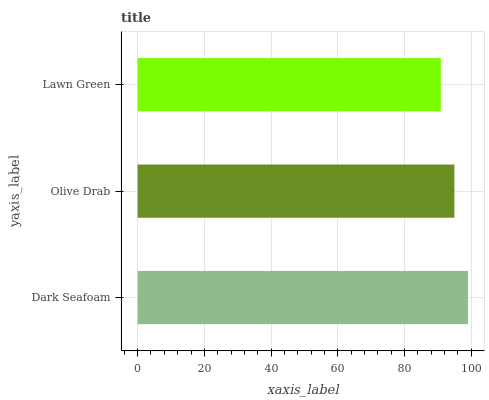Is Lawn Green the minimum?
Answer yes or no. Yes. Is Dark Seafoam the maximum?
Answer yes or no. Yes. Is Olive Drab the minimum?
Answer yes or no. No. Is Olive Drab the maximum?
Answer yes or no. No. Is Dark Seafoam greater than Olive Drab?
Answer yes or no. Yes. Is Olive Drab less than Dark Seafoam?
Answer yes or no. Yes. Is Olive Drab greater than Dark Seafoam?
Answer yes or no. No. Is Dark Seafoam less than Olive Drab?
Answer yes or no. No. Is Olive Drab the high median?
Answer yes or no. Yes. Is Olive Drab the low median?
Answer yes or no. Yes. Is Dark Seafoam the high median?
Answer yes or no. No. Is Lawn Green the low median?
Answer yes or no. No. 